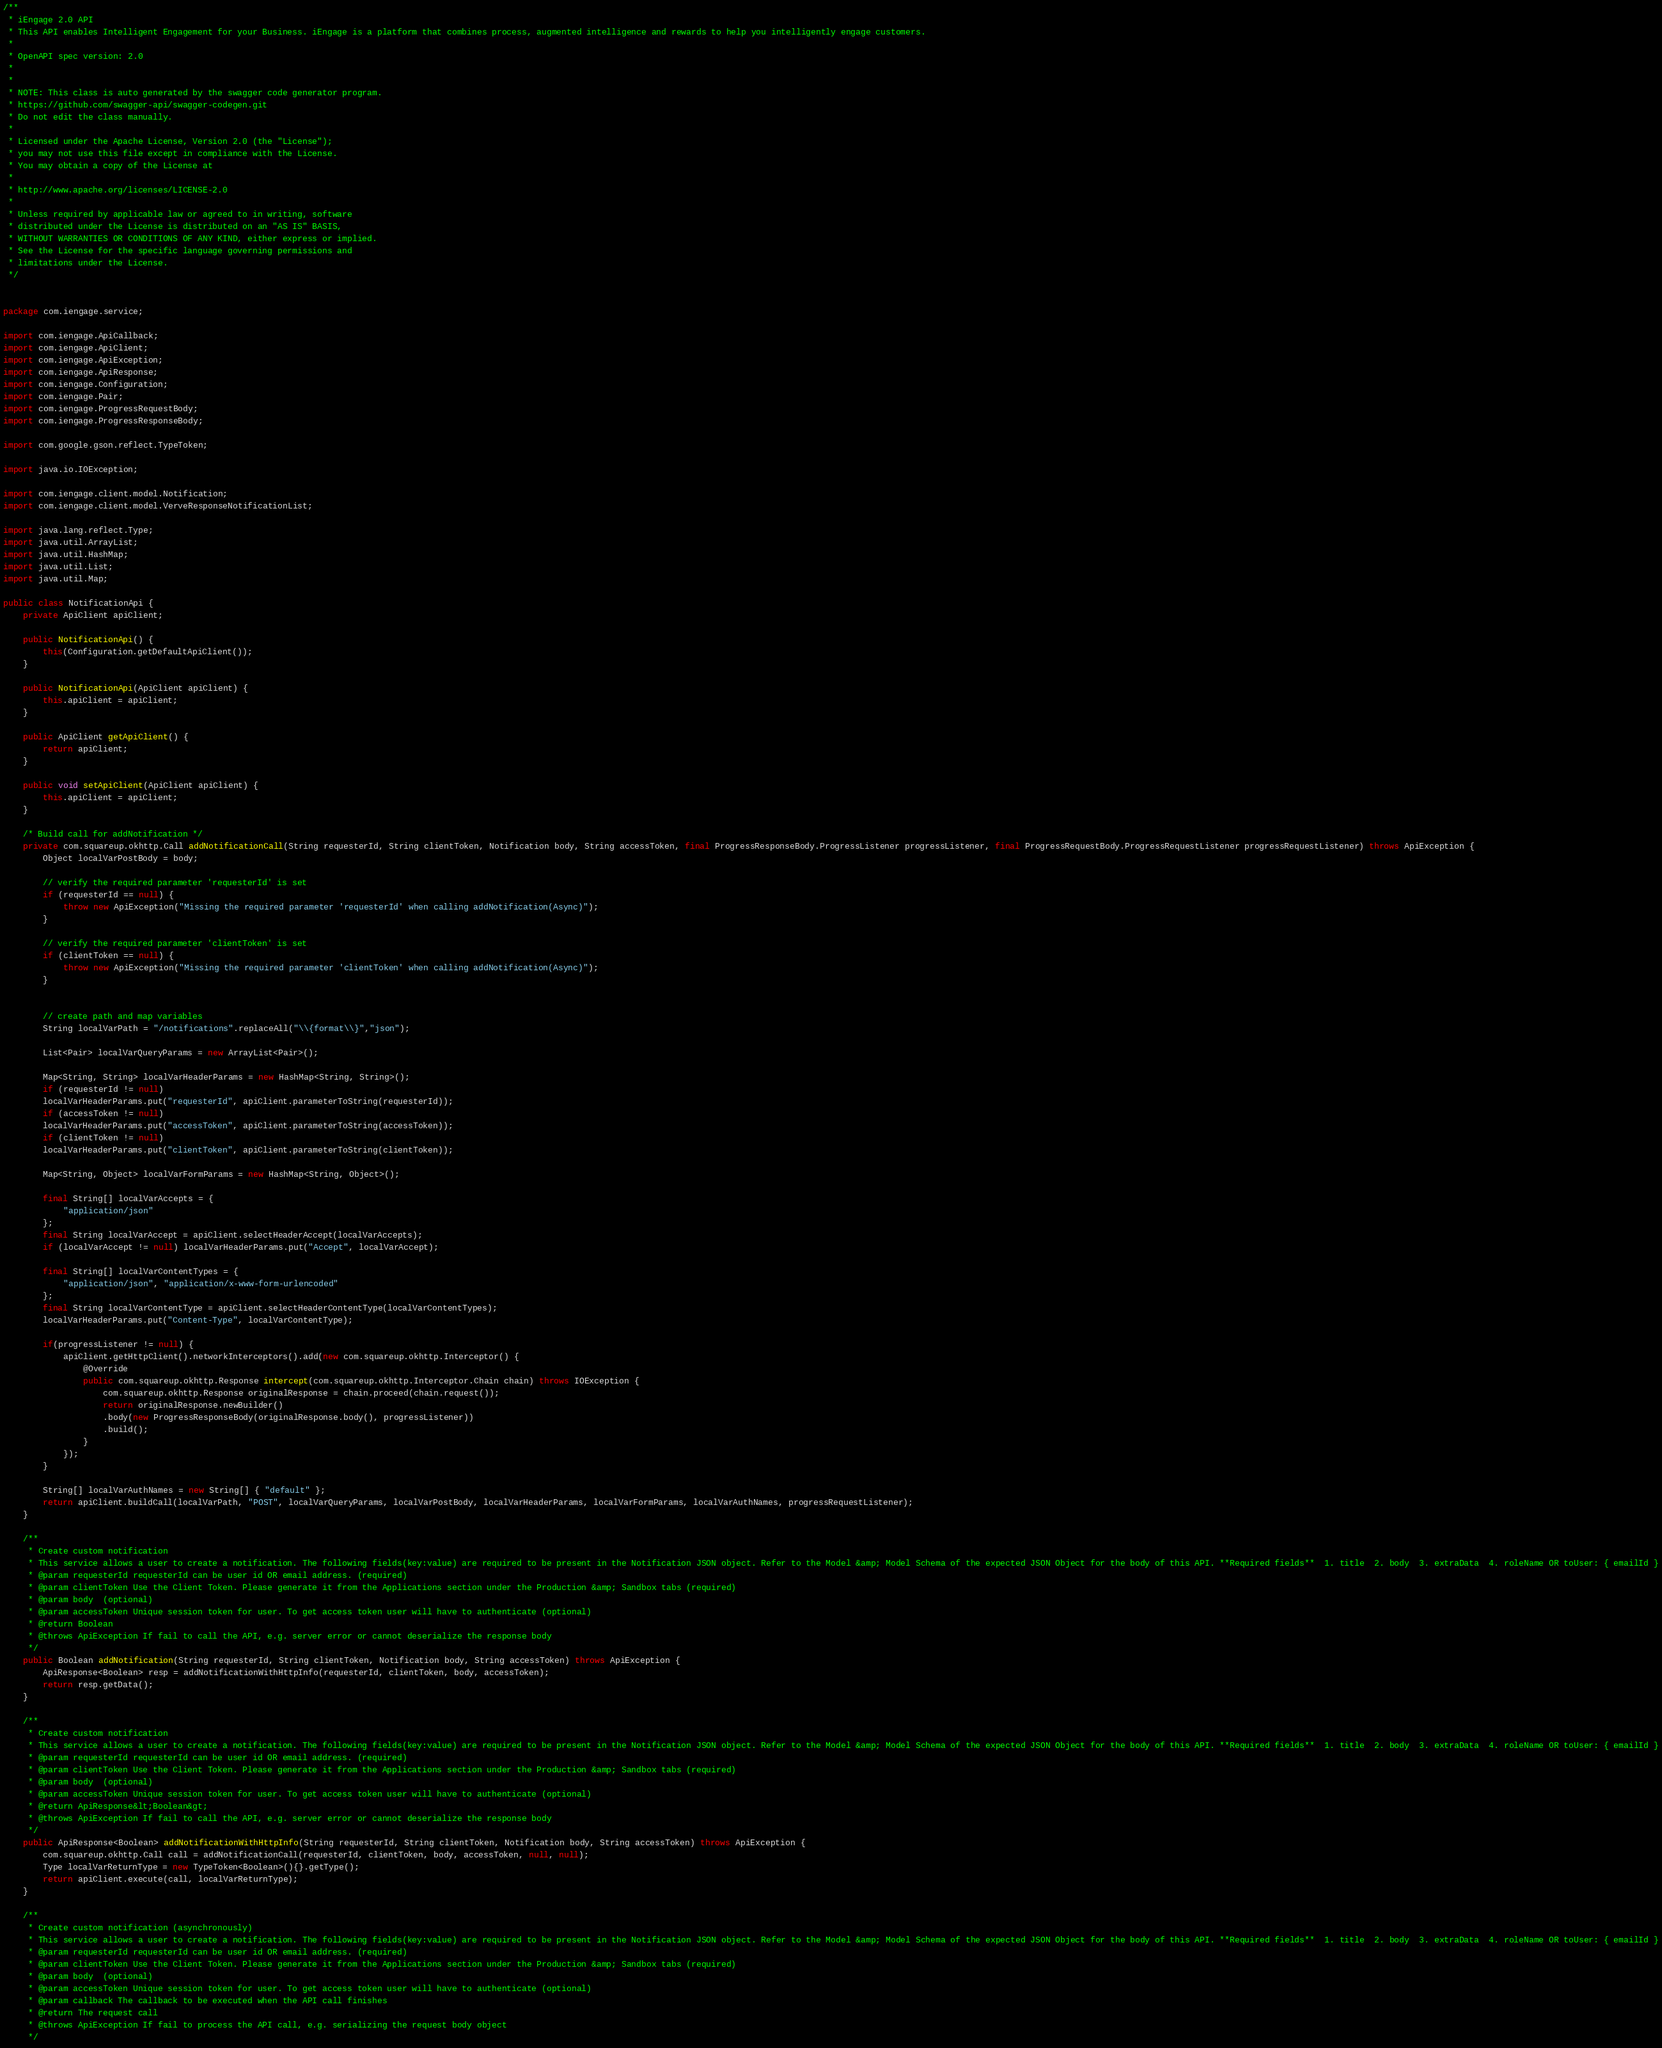<code> <loc_0><loc_0><loc_500><loc_500><_Java_>/**
 * iEngage 2.0 API
 * This API enables Intelligent Engagement for your Business. iEngage is a platform that combines process, augmented intelligence and rewards to help you intelligently engage customers.
 *
 * OpenAPI spec version: 2.0
 * 
 *
 * NOTE: This class is auto generated by the swagger code generator program.
 * https://github.com/swagger-api/swagger-codegen.git
 * Do not edit the class manually.
 *
 * Licensed under the Apache License, Version 2.0 (the "License");
 * you may not use this file except in compliance with the License.
 * You may obtain a copy of the License at
 *
 * http://www.apache.org/licenses/LICENSE-2.0
 *
 * Unless required by applicable law or agreed to in writing, software
 * distributed under the License is distributed on an "AS IS" BASIS,
 * WITHOUT WARRANTIES OR CONDITIONS OF ANY KIND, either express or implied.
 * See the License for the specific language governing permissions and
 * limitations under the License.
 */


package com.iengage.service;

import com.iengage.ApiCallback;
import com.iengage.ApiClient;
import com.iengage.ApiException;
import com.iengage.ApiResponse;
import com.iengage.Configuration;
import com.iengage.Pair;
import com.iengage.ProgressRequestBody;
import com.iengage.ProgressResponseBody;

import com.google.gson.reflect.TypeToken;

import java.io.IOException;

import com.iengage.client.model.Notification;
import com.iengage.client.model.VerveResponseNotificationList;

import java.lang.reflect.Type;
import java.util.ArrayList;
import java.util.HashMap;
import java.util.List;
import java.util.Map;

public class NotificationApi {
    private ApiClient apiClient;

    public NotificationApi() {
        this(Configuration.getDefaultApiClient());
    }

    public NotificationApi(ApiClient apiClient) {
        this.apiClient = apiClient;
    }

    public ApiClient getApiClient() {
        return apiClient;
    }

    public void setApiClient(ApiClient apiClient) {
        this.apiClient = apiClient;
    }

    /* Build call for addNotification */
    private com.squareup.okhttp.Call addNotificationCall(String requesterId, String clientToken, Notification body, String accessToken, final ProgressResponseBody.ProgressListener progressListener, final ProgressRequestBody.ProgressRequestListener progressRequestListener) throws ApiException {
        Object localVarPostBody = body;
        
        // verify the required parameter 'requesterId' is set
        if (requesterId == null) {
            throw new ApiException("Missing the required parameter 'requesterId' when calling addNotification(Async)");
        }
        
        // verify the required parameter 'clientToken' is set
        if (clientToken == null) {
            throw new ApiException("Missing the required parameter 'clientToken' when calling addNotification(Async)");
        }
        

        // create path and map variables
        String localVarPath = "/notifications".replaceAll("\\{format\\}","json");

        List<Pair> localVarQueryParams = new ArrayList<Pair>();

        Map<String, String> localVarHeaderParams = new HashMap<String, String>();
        if (requesterId != null)
        localVarHeaderParams.put("requesterId", apiClient.parameterToString(requesterId));
        if (accessToken != null)
        localVarHeaderParams.put("accessToken", apiClient.parameterToString(accessToken));
        if (clientToken != null)
        localVarHeaderParams.put("clientToken", apiClient.parameterToString(clientToken));

        Map<String, Object> localVarFormParams = new HashMap<String, Object>();

        final String[] localVarAccepts = {
            "application/json"
        };
        final String localVarAccept = apiClient.selectHeaderAccept(localVarAccepts);
        if (localVarAccept != null) localVarHeaderParams.put("Accept", localVarAccept);

        final String[] localVarContentTypes = {
            "application/json", "application/x-www-form-urlencoded"
        };
        final String localVarContentType = apiClient.selectHeaderContentType(localVarContentTypes);
        localVarHeaderParams.put("Content-Type", localVarContentType);

        if(progressListener != null) {
            apiClient.getHttpClient().networkInterceptors().add(new com.squareup.okhttp.Interceptor() {
                @Override
                public com.squareup.okhttp.Response intercept(com.squareup.okhttp.Interceptor.Chain chain) throws IOException {
                    com.squareup.okhttp.Response originalResponse = chain.proceed(chain.request());
                    return originalResponse.newBuilder()
                    .body(new ProgressResponseBody(originalResponse.body(), progressListener))
                    .build();
                }
            });
        }

        String[] localVarAuthNames = new String[] { "default" };
        return apiClient.buildCall(localVarPath, "POST", localVarQueryParams, localVarPostBody, localVarHeaderParams, localVarFormParams, localVarAuthNames, progressRequestListener);
    }

    /**
     * Create custom notification
     * This service allows a user to create a notification. The following fields(key:value) are required to be present in the Notification JSON object. Refer to the Model &amp; Model Schema of the expected JSON Object for the body of this API. **Required fields**  1. title  2. body  3. extraData  4. roleName OR toUser: { emailId }
     * @param requesterId requesterId can be user id OR email address. (required)
     * @param clientToken Use the Client Token. Please generate it from the Applications section under the Production &amp; Sandbox tabs (required)
     * @param body  (optional)
     * @param accessToken Unique session token for user. To get access token user will have to authenticate (optional)
     * @return Boolean
     * @throws ApiException If fail to call the API, e.g. server error or cannot deserialize the response body
     */
    public Boolean addNotification(String requesterId, String clientToken, Notification body, String accessToken) throws ApiException {
        ApiResponse<Boolean> resp = addNotificationWithHttpInfo(requesterId, clientToken, body, accessToken);
        return resp.getData();
    }

    /**
     * Create custom notification
     * This service allows a user to create a notification. The following fields(key:value) are required to be present in the Notification JSON object. Refer to the Model &amp; Model Schema of the expected JSON Object for the body of this API. **Required fields**  1. title  2. body  3. extraData  4. roleName OR toUser: { emailId }
     * @param requesterId requesterId can be user id OR email address. (required)
     * @param clientToken Use the Client Token. Please generate it from the Applications section under the Production &amp; Sandbox tabs (required)
     * @param body  (optional)
     * @param accessToken Unique session token for user. To get access token user will have to authenticate (optional)
     * @return ApiResponse&lt;Boolean&gt;
     * @throws ApiException If fail to call the API, e.g. server error or cannot deserialize the response body
     */
    public ApiResponse<Boolean> addNotificationWithHttpInfo(String requesterId, String clientToken, Notification body, String accessToken) throws ApiException {
        com.squareup.okhttp.Call call = addNotificationCall(requesterId, clientToken, body, accessToken, null, null);
        Type localVarReturnType = new TypeToken<Boolean>(){}.getType();
        return apiClient.execute(call, localVarReturnType);
    }

    /**
     * Create custom notification (asynchronously)
     * This service allows a user to create a notification. The following fields(key:value) are required to be present in the Notification JSON object. Refer to the Model &amp; Model Schema of the expected JSON Object for the body of this API. **Required fields**  1. title  2. body  3. extraData  4. roleName OR toUser: { emailId }
     * @param requesterId requesterId can be user id OR email address. (required)
     * @param clientToken Use the Client Token. Please generate it from the Applications section under the Production &amp; Sandbox tabs (required)
     * @param body  (optional)
     * @param accessToken Unique session token for user. To get access token user will have to authenticate (optional)
     * @param callback The callback to be executed when the API call finishes
     * @return The request call
     * @throws ApiException If fail to process the API call, e.g. serializing the request body object
     */</code> 